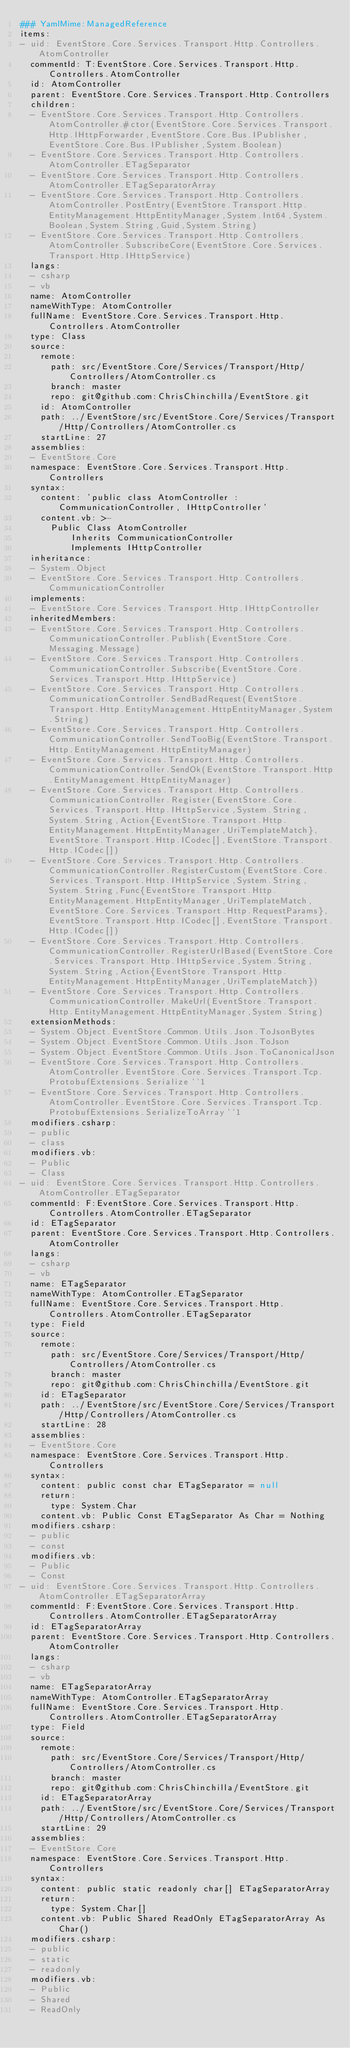Convert code to text. <code><loc_0><loc_0><loc_500><loc_500><_YAML_>### YamlMime:ManagedReference
items:
- uid: EventStore.Core.Services.Transport.Http.Controllers.AtomController
  commentId: T:EventStore.Core.Services.Transport.Http.Controllers.AtomController
  id: AtomController
  parent: EventStore.Core.Services.Transport.Http.Controllers
  children:
  - EventStore.Core.Services.Transport.Http.Controllers.AtomController.#ctor(EventStore.Core.Services.Transport.Http.IHttpForwarder,EventStore.Core.Bus.IPublisher,EventStore.Core.Bus.IPublisher,System.Boolean)
  - EventStore.Core.Services.Transport.Http.Controllers.AtomController.ETagSeparator
  - EventStore.Core.Services.Transport.Http.Controllers.AtomController.ETagSeparatorArray
  - EventStore.Core.Services.Transport.Http.Controllers.AtomController.PostEntry(EventStore.Transport.Http.EntityManagement.HttpEntityManager,System.Int64,System.Boolean,System.String,Guid,System.String)
  - EventStore.Core.Services.Transport.Http.Controllers.AtomController.SubscribeCore(EventStore.Core.Services.Transport.Http.IHttpService)
  langs:
  - csharp
  - vb
  name: AtomController
  nameWithType: AtomController
  fullName: EventStore.Core.Services.Transport.Http.Controllers.AtomController
  type: Class
  source:
    remote:
      path: src/EventStore.Core/Services/Transport/Http/Controllers/AtomController.cs
      branch: master
      repo: git@github.com:ChrisChinchilla/EventStore.git
    id: AtomController
    path: ../EventStore/src/EventStore.Core/Services/Transport/Http/Controllers/AtomController.cs
    startLine: 27
  assemblies:
  - EventStore.Core
  namespace: EventStore.Core.Services.Transport.Http.Controllers
  syntax:
    content: 'public class AtomController : CommunicationController, IHttpController'
    content.vb: >-
      Public Class AtomController
          Inherits CommunicationController
          Implements IHttpController
  inheritance:
  - System.Object
  - EventStore.Core.Services.Transport.Http.Controllers.CommunicationController
  implements:
  - EventStore.Core.Services.Transport.Http.IHttpController
  inheritedMembers:
  - EventStore.Core.Services.Transport.Http.Controllers.CommunicationController.Publish(EventStore.Core.Messaging.Message)
  - EventStore.Core.Services.Transport.Http.Controllers.CommunicationController.Subscribe(EventStore.Core.Services.Transport.Http.IHttpService)
  - EventStore.Core.Services.Transport.Http.Controllers.CommunicationController.SendBadRequest(EventStore.Transport.Http.EntityManagement.HttpEntityManager,System.String)
  - EventStore.Core.Services.Transport.Http.Controllers.CommunicationController.SendTooBig(EventStore.Transport.Http.EntityManagement.HttpEntityManager)
  - EventStore.Core.Services.Transport.Http.Controllers.CommunicationController.SendOk(EventStore.Transport.Http.EntityManagement.HttpEntityManager)
  - EventStore.Core.Services.Transport.Http.Controllers.CommunicationController.Register(EventStore.Core.Services.Transport.Http.IHttpService,System.String,System.String,Action{EventStore.Transport.Http.EntityManagement.HttpEntityManager,UriTemplateMatch},EventStore.Transport.Http.ICodec[],EventStore.Transport.Http.ICodec[])
  - EventStore.Core.Services.Transport.Http.Controllers.CommunicationController.RegisterCustom(EventStore.Core.Services.Transport.Http.IHttpService,System.String,System.String,Func{EventStore.Transport.Http.EntityManagement.HttpEntityManager,UriTemplateMatch,EventStore.Core.Services.Transport.Http.RequestParams},EventStore.Transport.Http.ICodec[],EventStore.Transport.Http.ICodec[])
  - EventStore.Core.Services.Transport.Http.Controllers.CommunicationController.RegisterUrlBased(EventStore.Core.Services.Transport.Http.IHttpService,System.String,System.String,Action{EventStore.Transport.Http.EntityManagement.HttpEntityManager,UriTemplateMatch})
  - EventStore.Core.Services.Transport.Http.Controllers.CommunicationController.MakeUrl(EventStore.Transport.Http.EntityManagement.HttpEntityManager,System.String)
  extensionMethods:
  - System.Object.EventStore.Common.Utils.Json.ToJsonBytes
  - System.Object.EventStore.Common.Utils.Json.ToJson
  - System.Object.EventStore.Common.Utils.Json.ToCanonicalJson
  - EventStore.Core.Services.Transport.Http.Controllers.AtomController.EventStore.Core.Services.Transport.Tcp.ProtobufExtensions.Serialize``1
  - EventStore.Core.Services.Transport.Http.Controllers.AtomController.EventStore.Core.Services.Transport.Tcp.ProtobufExtensions.SerializeToArray``1
  modifiers.csharp:
  - public
  - class
  modifiers.vb:
  - Public
  - Class
- uid: EventStore.Core.Services.Transport.Http.Controllers.AtomController.ETagSeparator
  commentId: F:EventStore.Core.Services.Transport.Http.Controllers.AtomController.ETagSeparator
  id: ETagSeparator
  parent: EventStore.Core.Services.Transport.Http.Controllers.AtomController
  langs:
  - csharp
  - vb
  name: ETagSeparator
  nameWithType: AtomController.ETagSeparator
  fullName: EventStore.Core.Services.Transport.Http.Controllers.AtomController.ETagSeparator
  type: Field
  source:
    remote:
      path: src/EventStore.Core/Services/Transport/Http/Controllers/AtomController.cs
      branch: master
      repo: git@github.com:ChrisChinchilla/EventStore.git
    id: ETagSeparator
    path: ../EventStore/src/EventStore.Core/Services/Transport/Http/Controllers/AtomController.cs
    startLine: 28
  assemblies:
  - EventStore.Core
  namespace: EventStore.Core.Services.Transport.Http.Controllers
  syntax:
    content: public const char ETagSeparator = null
    return:
      type: System.Char
    content.vb: Public Const ETagSeparator As Char = Nothing
  modifiers.csharp:
  - public
  - const
  modifiers.vb:
  - Public
  - Const
- uid: EventStore.Core.Services.Transport.Http.Controllers.AtomController.ETagSeparatorArray
  commentId: F:EventStore.Core.Services.Transport.Http.Controllers.AtomController.ETagSeparatorArray
  id: ETagSeparatorArray
  parent: EventStore.Core.Services.Transport.Http.Controllers.AtomController
  langs:
  - csharp
  - vb
  name: ETagSeparatorArray
  nameWithType: AtomController.ETagSeparatorArray
  fullName: EventStore.Core.Services.Transport.Http.Controllers.AtomController.ETagSeparatorArray
  type: Field
  source:
    remote:
      path: src/EventStore.Core/Services/Transport/Http/Controllers/AtomController.cs
      branch: master
      repo: git@github.com:ChrisChinchilla/EventStore.git
    id: ETagSeparatorArray
    path: ../EventStore/src/EventStore.Core/Services/Transport/Http/Controllers/AtomController.cs
    startLine: 29
  assemblies:
  - EventStore.Core
  namespace: EventStore.Core.Services.Transport.Http.Controllers
  syntax:
    content: public static readonly char[] ETagSeparatorArray
    return:
      type: System.Char[]
    content.vb: Public Shared ReadOnly ETagSeparatorArray As Char()
  modifiers.csharp:
  - public
  - static
  - readonly
  modifiers.vb:
  - Public
  - Shared
  - ReadOnly</code> 